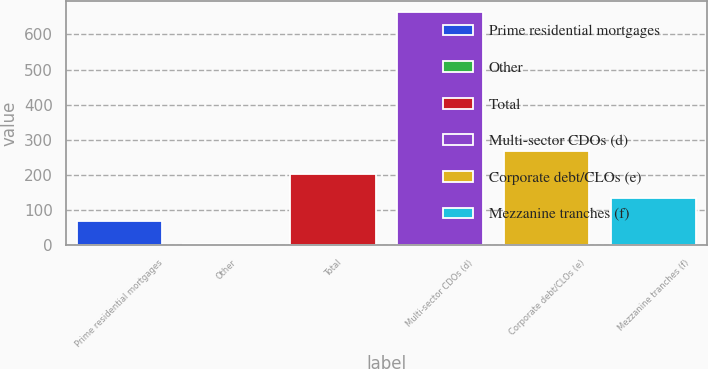Convert chart. <chart><loc_0><loc_0><loc_500><loc_500><bar_chart><fcel>Prime residential mortgages<fcel>Other<fcel>Total<fcel>Multi-sector CDOs (d)<fcel>Corporate debt/CLOs (e)<fcel>Mezzanine tranches (f)<nl><fcel>69.9<fcel>4<fcel>201.7<fcel>663<fcel>267.6<fcel>135.8<nl></chart> 